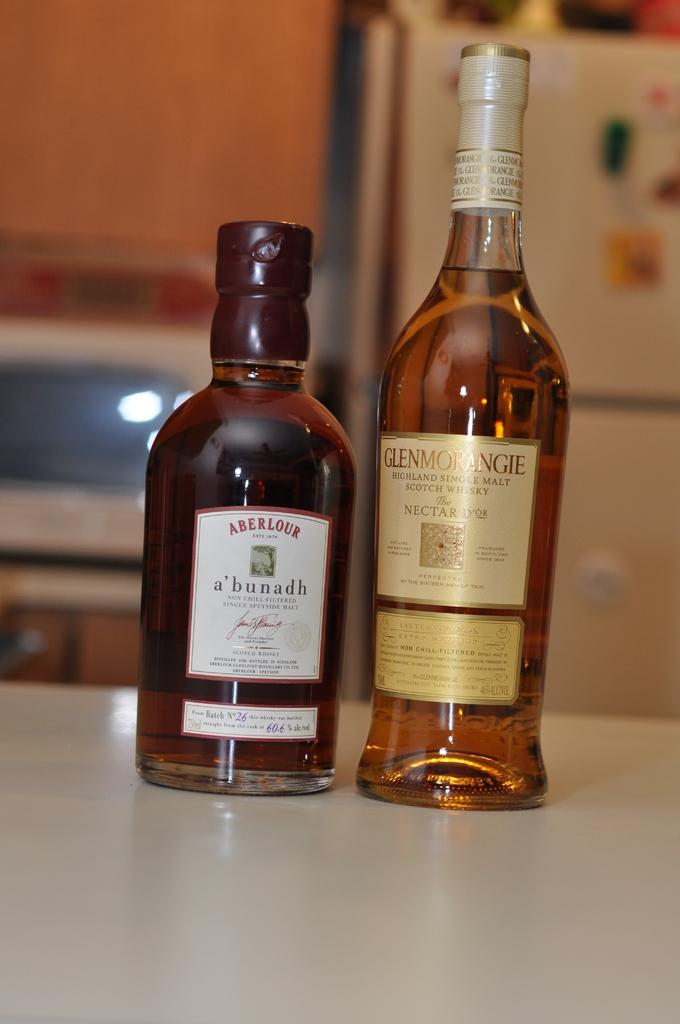<image>
Relay a brief, clear account of the picture shown. A bottle of Aberlour whiskey and Glenmorangie whiskey sit on a counter. 